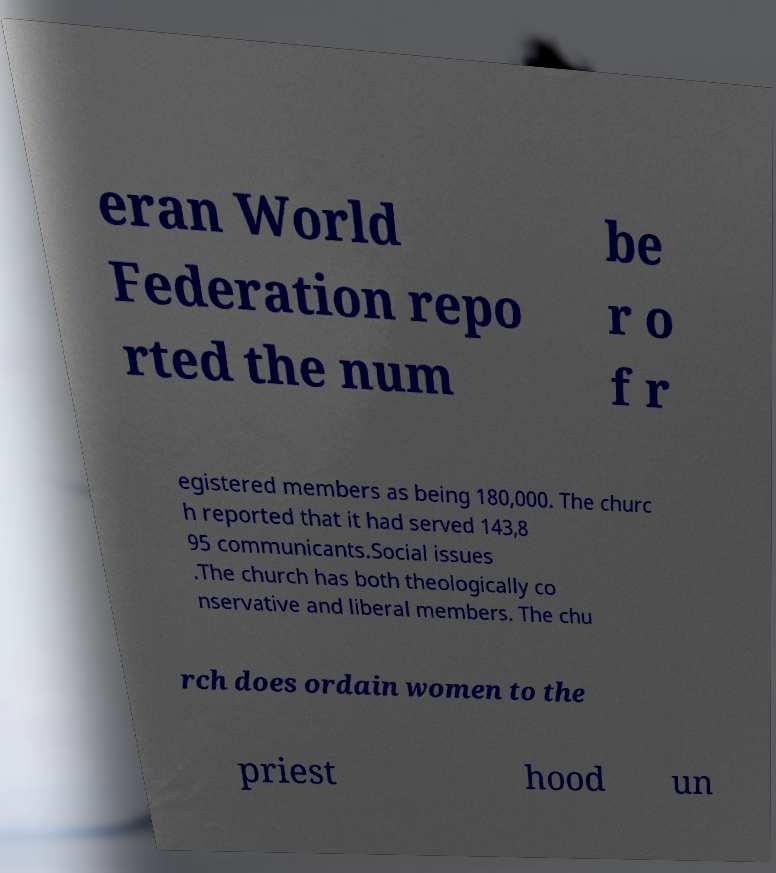There's text embedded in this image that I need extracted. Can you transcribe it verbatim? eran World Federation repo rted the num be r o f r egistered members as being 180,000. The churc h reported that it had served 143,8 95 communicants.Social issues .The church has both theologically co nservative and liberal members. The chu rch does ordain women to the priest hood un 